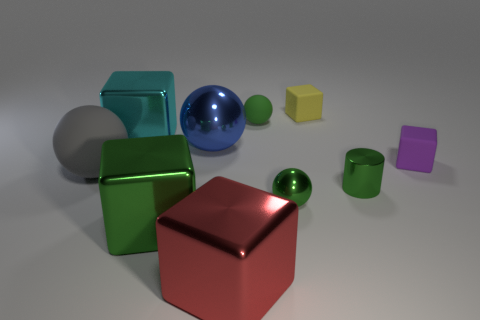Subtract all cyan cubes. How many cubes are left? 4 Subtract 0 cyan cylinders. How many objects are left? 10 Subtract all spheres. How many objects are left? 6 Subtract 1 cylinders. How many cylinders are left? 0 Subtract all brown balls. Subtract all blue blocks. How many balls are left? 4 Subtract all green cubes. How many red balls are left? 0 Subtract all big green things. Subtract all gray balls. How many objects are left? 8 Add 4 small purple cubes. How many small purple cubes are left? 5 Add 1 small green things. How many small green things exist? 4 Subtract all blue balls. How many balls are left? 3 